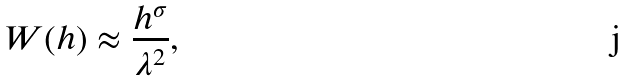Convert formula to latex. <formula><loc_0><loc_0><loc_500><loc_500>W ( h ) \approx \frac { h ^ { \sigma } } { \lambda ^ { 2 } } \text {,}</formula> 